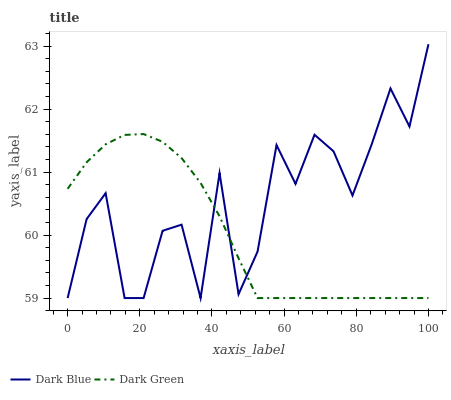Does Dark Green have the maximum area under the curve?
Answer yes or no. No. Is Dark Green the roughest?
Answer yes or no. No. Does Dark Green have the highest value?
Answer yes or no. No. 